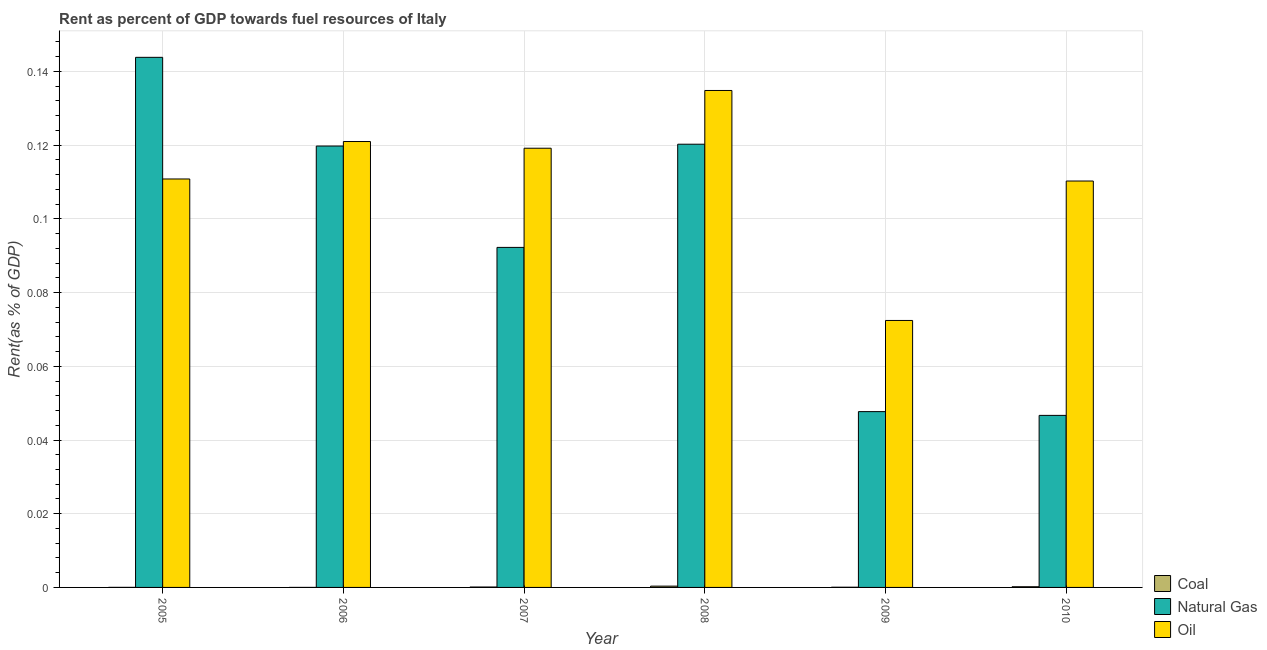How many different coloured bars are there?
Your answer should be compact. 3. Are the number of bars per tick equal to the number of legend labels?
Your response must be concise. Yes. How many bars are there on the 1st tick from the left?
Offer a terse response. 3. In how many cases, is the number of bars for a given year not equal to the number of legend labels?
Your answer should be very brief. 0. What is the rent towards coal in 2010?
Keep it short and to the point. 0. Across all years, what is the maximum rent towards natural gas?
Keep it short and to the point. 0.14. Across all years, what is the minimum rent towards natural gas?
Make the answer very short. 0.05. In which year was the rent towards coal minimum?
Make the answer very short. 2006. What is the total rent towards natural gas in the graph?
Your response must be concise. 0.57. What is the difference between the rent towards natural gas in 2008 and that in 2010?
Your answer should be compact. 0.07. What is the difference between the rent towards oil in 2006 and the rent towards natural gas in 2005?
Make the answer very short. 0.01. What is the average rent towards oil per year?
Provide a short and direct response. 0.11. In the year 2005, what is the difference between the rent towards oil and rent towards coal?
Your response must be concise. 0. In how many years, is the rent towards natural gas greater than 0.064 %?
Provide a succinct answer. 4. What is the ratio of the rent towards coal in 2005 to that in 2007?
Offer a very short reply. 0.14. What is the difference between the highest and the second highest rent towards natural gas?
Keep it short and to the point. 0.02. What is the difference between the highest and the lowest rent towards natural gas?
Keep it short and to the point. 0.1. What does the 3rd bar from the left in 2009 represents?
Your response must be concise. Oil. What does the 3rd bar from the right in 2005 represents?
Offer a very short reply. Coal. How many bars are there?
Provide a succinct answer. 18. Are all the bars in the graph horizontal?
Your answer should be very brief. No. Are the values on the major ticks of Y-axis written in scientific E-notation?
Your answer should be very brief. No. Does the graph contain any zero values?
Your response must be concise. No. How are the legend labels stacked?
Offer a very short reply. Vertical. What is the title of the graph?
Your answer should be very brief. Rent as percent of GDP towards fuel resources of Italy. What is the label or title of the Y-axis?
Make the answer very short. Rent(as % of GDP). What is the Rent(as % of GDP) of Coal in 2005?
Your answer should be very brief. 1.52938665315344e-5. What is the Rent(as % of GDP) of Natural Gas in 2005?
Provide a short and direct response. 0.14. What is the Rent(as % of GDP) in Oil in 2005?
Make the answer very short. 0.11. What is the Rent(as % of GDP) of Coal in 2006?
Offer a terse response. 5.16849671469394e-6. What is the Rent(as % of GDP) of Natural Gas in 2006?
Your answer should be compact. 0.12. What is the Rent(as % of GDP) of Oil in 2006?
Provide a short and direct response. 0.12. What is the Rent(as % of GDP) in Coal in 2007?
Your answer should be compact. 0. What is the Rent(as % of GDP) in Natural Gas in 2007?
Offer a very short reply. 0.09. What is the Rent(as % of GDP) of Oil in 2007?
Make the answer very short. 0.12. What is the Rent(as % of GDP) of Coal in 2008?
Give a very brief answer. 0. What is the Rent(as % of GDP) of Natural Gas in 2008?
Provide a short and direct response. 0.12. What is the Rent(as % of GDP) in Oil in 2008?
Give a very brief answer. 0.13. What is the Rent(as % of GDP) of Coal in 2009?
Keep it short and to the point. 5.380155600468061e-5. What is the Rent(as % of GDP) of Natural Gas in 2009?
Provide a short and direct response. 0.05. What is the Rent(as % of GDP) of Oil in 2009?
Provide a short and direct response. 0.07. What is the Rent(as % of GDP) in Coal in 2010?
Provide a short and direct response. 0. What is the Rent(as % of GDP) of Natural Gas in 2010?
Make the answer very short. 0.05. What is the Rent(as % of GDP) of Oil in 2010?
Provide a succinct answer. 0.11. Across all years, what is the maximum Rent(as % of GDP) in Coal?
Provide a short and direct response. 0. Across all years, what is the maximum Rent(as % of GDP) of Natural Gas?
Your answer should be compact. 0.14. Across all years, what is the maximum Rent(as % of GDP) of Oil?
Offer a very short reply. 0.13. Across all years, what is the minimum Rent(as % of GDP) of Coal?
Your response must be concise. 5.16849671469394e-6. Across all years, what is the minimum Rent(as % of GDP) of Natural Gas?
Your answer should be very brief. 0.05. Across all years, what is the minimum Rent(as % of GDP) in Oil?
Offer a very short reply. 0.07. What is the total Rent(as % of GDP) in Coal in the graph?
Keep it short and to the point. 0. What is the total Rent(as % of GDP) in Natural Gas in the graph?
Give a very brief answer. 0.57. What is the total Rent(as % of GDP) of Oil in the graph?
Offer a terse response. 0.67. What is the difference between the Rent(as % of GDP) in Natural Gas in 2005 and that in 2006?
Provide a succinct answer. 0.02. What is the difference between the Rent(as % of GDP) of Oil in 2005 and that in 2006?
Provide a short and direct response. -0.01. What is the difference between the Rent(as % of GDP) in Coal in 2005 and that in 2007?
Your answer should be very brief. -0. What is the difference between the Rent(as % of GDP) in Natural Gas in 2005 and that in 2007?
Provide a succinct answer. 0.05. What is the difference between the Rent(as % of GDP) of Oil in 2005 and that in 2007?
Provide a short and direct response. -0.01. What is the difference between the Rent(as % of GDP) in Coal in 2005 and that in 2008?
Give a very brief answer. -0. What is the difference between the Rent(as % of GDP) of Natural Gas in 2005 and that in 2008?
Your answer should be very brief. 0.02. What is the difference between the Rent(as % of GDP) of Oil in 2005 and that in 2008?
Offer a terse response. -0.02. What is the difference between the Rent(as % of GDP) of Natural Gas in 2005 and that in 2009?
Make the answer very short. 0.1. What is the difference between the Rent(as % of GDP) of Oil in 2005 and that in 2009?
Offer a very short reply. 0.04. What is the difference between the Rent(as % of GDP) in Coal in 2005 and that in 2010?
Provide a short and direct response. -0. What is the difference between the Rent(as % of GDP) in Natural Gas in 2005 and that in 2010?
Your answer should be compact. 0.1. What is the difference between the Rent(as % of GDP) of Oil in 2005 and that in 2010?
Your response must be concise. 0. What is the difference between the Rent(as % of GDP) of Coal in 2006 and that in 2007?
Make the answer very short. -0. What is the difference between the Rent(as % of GDP) in Natural Gas in 2006 and that in 2007?
Make the answer very short. 0.03. What is the difference between the Rent(as % of GDP) of Oil in 2006 and that in 2007?
Provide a short and direct response. 0. What is the difference between the Rent(as % of GDP) of Coal in 2006 and that in 2008?
Your response must be concise. -0. What is the difference between the Rent(as % of GDP) of Natural Gas in 2006 and that in 2008?
Keep it short and to the point. -0. What is the difference between the Rent(as % of GDP) of Oil in 2006 and that in 2008?
Your answer should be very brief. -0.01. What is the difference between the Rent(as % of GDP) in Coal in 2006 and that in 2009?
Ensure brevity in your answer.  -0. What is the difference between the Rent(as % of GDP) of Natural Gas in 2006 and that in 2009?
Ensure brevity in your answer.  0.07. What is the difference between the Rent(as % of GDP) of Oil in 2006 and that in 2009?
Offer a terse response. 0.05. What is the difference between the Rent(as % of GDP) of Coal in 2006 and that in 2010?
Provide a short and direct response. -0. What is the difference between the Rent(as % of GDP) of Natural Gas in 2006 and that in 2010?
Offer a very short reply. 0.07. What is the difference between the Rent(as % of GDP) of Oil in 2006 and that in 2010?
Make the answer very short. 0.01. What is the difference between the Rent(as % of GDP) of Coal in 2007 and that in 2008?
Give a very brief answer. -0. What is the difference between the Rent(as % of GDP) in Natural Gas in 2007 and that in 2008?
Make the answer very short. -0.03. What is the difference between the Rent(as % of GDP) in Oil in 2007 and that in 2008?
Your answer should be very brief. -0.02. What is the difference between the Rent(as % of GDP) in Natural Gas in 2007 and that in 2009?
Offer a very short reply. 0.04. What is the difference between the Rent(as % of GDP) of Oil in 2007 and that in 2009?
Provide a short and direct response. 0.05. What is the difference between the Rent(as % of GDP) in Coal in 2007 and that in 2010?
Your response must be concise. -0. What is the difference between the Rent(as % of GDP) in Natural Gas in 2007 and that in 2010?
Ensure brevity in your answer.  0.05. What is the difference between the Rent(as % of GDP) of Oil in 2007 and that in 2010?
Keep it short and to the point. 0.01. What is the difference between the Rent(as % of GDP) in Natural Gas in 2008 and that in 2009?
Offer a terse response. 0.07. What is the difference between the Rent(as % of GDP) in Oil in 2008 and that in 2009?
Your answer should be compact. 0.06. What is the difference between the Rent(as % of GDP) in Natural Gas in 2008 and that in 2010?
Provide a succinct answer. 0.07. What is the difference between the Rent(as % of GDP) of Oil in 2008 and that in 2010?
Provide a short and direct response. 0.02. What is the difference between the Rent(as % of GDP) of Coal in 2009 and that in 2010?
Offer a terse response. -0. What is the difference between the Rent(as % of GDP) in Oil in 2009 and that in 2010?
Provide a succinct answer. -0.04. What is the difference between the Rent(as % of GDP) of Coal in 2005 and the Rent(as % of GDP) of Natural Gas in 2006?
Give a very brief answer. -0.12. What is the difference between the Rent(as % of GDP) in Coal in 2005 and the Rent(as % of GDP) in Oil in 2006?
Your response must be concise. -0.12. What is the difference between the Rent(as % of GDP) in Natural Gas in 2005 and the Rent(as % of GDP) in Oil in 2006?
Your answer should be compact. 0.02. What is the difference between the Rent(as % of GDP) of Coal in 2005 and the Rent(as % of GDP) of Natural Gas in 2007?
Keep it short and to the point. -0.09. What is the difference between the Rent(as % of GDP) in Coal in 2005 and the Rent(as % of GDP) in Oil in 2007?
Keep it short and to the point. -0.12. What is the difference between the Rent(as % of GDP) in Natural Gas in 2005 and the Rent(as % of GDP) in Oil in 2007?
Your answer should be very brief. 0.02. What is the difference between the Rent(as % of GDP) in Coal in 2005 and the Rent(as % of GDP) in Natural Gas in 2008?
Offer a very short reply. -0.12. What is the difference between the Rent(as % of GDP) in Coal in 2005 and the Rent(as % of GDP) in Oil in 2008?
Your response must be concise. -0.13. What is the difference between the Rent(as % of GDP) in Natural Gas in 2005 and the Rent(as % of GDP) in Oil in 2008?
Offer a terse response. 0.01. What is the difference between the Rent(as % of GDP) of Coal in 2005 and the Rent(as % of GDP) of Natural Gas in 2009?
Offer a very short reply. -0.05. What is the difference between the Rent(as % of GDP) of Coal in 2005 and the Rent(as % of GDP) of Oil in 2009?
Offer a terse response. -0.07. What is the difference between the Rent(as % of GDP) of Natural Gas in 2005 and the Rent(as % of GDP) of Oil in 2009?
Offer a terse response. 0.07. What is the difference between the Rent(as % of GDP) of Coal in 2005 and the Rent(as % of GDP) of Natural Gas in 2010?
Make the answer very short. -0.05. What is the difference between the Rent(as % of GDP) of Coal in 2005 and the Rent(as % of GDP) of Oil in 2010?
Offer a very short reply. -0.11. What is the difference between the Rent(as % of GDP) of Natural Gas in 2005 and the Rent(as % of GDP) of Oil in 2010?
Provide a succinct answer. 0.03. What is the difference between the Rent(as % of GDP) in Coal in 2006 and the Rent(as % of GDP) in Natural Gas in 2007?
Provide a short and direct response. -0.09. What is the difference between the Rent(as % of GDP) of Coal in 2006 and the Rent(as % of GDP) of Oil in 2007?
Ensure brevity in your answer.  -0.12. What is the difference between the Rent(as % of GDP) of Natural Gas in 2006 and the Rent(as % of GDP) of Oil in 2007?
Your answer should be compact. 0. What is the difference between the Rent(as % of GDP) of Coal in 2006 and the Rent(as % of GDP) of Natural Gas in 2008?
Offer a terse response. -0.12. What is the difference between the Rent(as % of GDP) in Coal in 2006 and the Rent(as % of GDP) in Oil in 2008?
Offer a terse response. -0.13. What is the difference between the Rent(as % of GDP) in Natural Gas in 2006 and the Rent(as % of GDP) in Oil in 2008?
Ensure brevity in your answer.  -0.02. What is the difference between the Rent(as % of GDP) in Coal in 2006 and the Rent(as % of GDP) in Natural Gas in 2009?
Ensure brevity in your answer.  -0.05. What is the difference between the Rent(as % of GDP) of Coal in 2006 and the Rent(as % of GDP) of Oil in 2009?
Keep it short and to the point. -0.07. What is the difference between the Rent(as % of GDP) of Natural Gas in 2006 and the Rent(as % of GDP) of Oil in 2009?
Make the answer very short. 0.05. What is the difference between the Rent(as % of GDP) in Coal in 2006 and the Rent(as % of GDP) in Natural Gas in 2010?
Give a very brief answer. -0.05. What is the difference between the Rent(as % of GDP) of Coal in 2006 and the Rent(as % of GDP) of Oil in 2010?
Provide a succinct answer. -0.11. What is the difference between the Rent(as % of GDP) in Natural Gas in 2006 and the Rent(as % of GDP) in Oil in 2010?
Keep it short and to the point. 0.01. What is the difference between the Rent(as % of GDP) of Coal in 2007 and the Rent(as % of GDP) of Natural Gas in 2008?
Keep it short and to the point. -0.12. What is the difference between the Rent(as % of GDP) in Coal in 2007 and the Rent(as % of GDP) in Oil in 2008?
Make the answer very short. -0.13. What is the difference between the Rent(as % of GDP) in Natural Gas in 2007 and the Rent(as % of GDP) in Oil in 2008?
Offer a terse response. -0.04. What is the difference between the Rent(as % of GDP) of Coal in 2007 and the Rent(as % of GDP) of Natural Gas in 2009?
Offer a terse response. -0.05. What is the difference between the Rent(as % of GDP) in Coal in 2007 and the Rent(as % of GDP) in Oil in 2009?
Your response must be concise. -0.07. What is the difference between the Rent(as % of GDP) of Natural Gas in 2007 and the Rent(as % of GDP) of Oil in 2009?
Provide a short and direct response. 0.02. What is the difference between the Rent(as % of GDP) of Coal in 2007 and the Rent(as % of GDP) of Natural Gas in 2010?
Keep it short and to the point. -0.05. What is the difference between the Rent(as % of GDP) of Coal in 2007 and the Rent(as % of GDP) of Oil in 2010?
Provide a short and direct response. -0.11. What is the difference between the Rent(as % of GDP) in Natural Gas in 2007 and the Rent(as % of GDP) in Oil in 2010?
Your answer should be compact. -0.02. What is the difference between the Rent(as % of GDP) in Coal in 2008 and the Rent(as % of GDP) in Natural Gas in 2009?
Make the answer very short. -0.05. What is the difference between the Rent(as % of GDP) of Coal in 2008 and the Rent(as % of GDP) of Oil in 2009?
Your response must be concise. -0.07. What is the difference between the Rent(as % of GDP) in Natural Gas in 2008 and the Rent(as % of GDP) in Oil in 2009?
Provide a succinct answer. 0.05. What is the difference between the Rent(as % of GDP) of Coal in 2008 and the Rent(as % of GDP) of Natural Gas in 2010?
Keep it short and to the point. -0.05. What is the difference between the Rent(as % of GDP) in Coal in 2008 and the Rent(as % of GDP) in Oil in 2010?
Offer a terse response. -0.11. What is the difference between the Rent(as % of GDP) of Natural Gas in 2008 and the Rent(as % of GDP) of Oil in 2010?
Ensure brevity in your answer.  0.01. What is the difference between the Rent(as % of GDP) in Coal in 2009 and the Rent(as % of GDP) in Natural Gas in 2010?
Offer a very short reply. -0.05. What is the difference between the Rent(as % of GDP) of Coal in 2009 and the Rent(as % of GDP) of Oil in 2010?
Ensure brevity in your answer.  -0.11. What is the difference between the Rent(as % of GDP) of Natural Gas in 2009 and the Rent(as % of GDP) of Oil in 2010?
Provide a succinct answer. -0.06. What is the average Rent(as % of GDP) of Coal per year?
Offer a terse response. 0. What is the average Rent(as % of GDP) in Natural Gas per year?
Provide a short and direct response. 0.1. What is the average Rent(as % of GDP) in Oil per year?
Offer a very short reply. 0.11. In the year 2005, what is the difference between the Rent(as % of GDP) in Coal and Rent(as % of GDP) in Natural Gas?
Give a very brief answer. -0.14. In the year 2005, what is the difference between the Rent(as % of GDP) of Coal and Rent(as % of GDP) of Oil?
Ensure brevity in your answer.  -0.11. In the year 2005, what is the difference between the Rent(as % of GDP) of Natural Gas and Rent(as % of GDP) of Oil?
Your response must be concise. 0.03. In the year 2006, what is the difference between the Rent(as % of GDP) in Coal and Rent(as % of GDP) in Natural Gas?
Provide a short and direct response. -0.12. In the year 2006, what is the difference between the Rent(as % of GDP) in Coal and Rent(as % of GDP) in Oil?
Make the answer very short. -0.12. In the year 2006, what is the difference between the Rent(as % of GDP) of Natural Gas and Rent(as % of GDP) of Oil?
Your response must be concise. -0. In the year 2007, what is the difference between the Rent(as % of GDP) in Coal and Rent(as % of GDP) in Natural Gas?
Offer a terse response. -0.09. In the year 2007, what is the difference between the Rent(as % of GDP) of Coal and Rent(as % of GDP) of Oil?
Give a very brief answer. -0.12. In the year 2007, what is the difference between the Rent(as % of GDP) of Natural Gas and Rent(as % of GDP) of Oil?
Your response must be concise. -0.03. In the year 2008, what is the difference between the Rent(as % of GDP) in Coal and Rent(as % of GDP) in Natural Gas?
Provide a short and direct response. -0.12. In the year 2008, what is the difference between the Rent(as % of GDP) in Coal and Rent(as % of GDP) in Oil?
Your response must be concise. -0.13. In the year 2008, what is the difference between the Rent(as % of GDP) of Natural Gas and Rent(as % of GDP) of Oil?
Provide a short and direct response. -0.01. In the year 2009, what is the difference between the Rent(as % of GDP) of Coal and Rent(as % of GDP) of Natural Gas?
Make the answer very short. -0.05. In the year 2009, what is the difference between the Rent(as % of GDP) in Coal and Rent(as % of GDP) in Oil?
Give a very brief answer. -0.07. In the year 2009, what is the difference between the Rent(as % of GDP) in Natural Gas and Rent(as % of GDP) in Oil?
Offer a very short reply. -0.02. In the year 2010, what is the difference between the Rent(as % of GDP) in Coal and Rent(as % of GDP) in Natural Gas?
Give a very brief answer. -0.05. In the year 2010, what is the difference between the Rent(as % of GDP) of Coal and Rent(as % of GDP) of Oil?
Provide a succinct answer. -0.11. In the year 2010, what is the difference between the Rent(as % of GDP) of Natural Gas and Rent(as % of GDP) of Oil?
Provide a succinct answer. -0.06. What is the ratio of the Rent(as % of GDP) in Coal in 2005 to that in 2006?
Your answer should be compact. 2.96. What is the ratio of the Rent(as % of GDP) in Natural Gas in 2005 to that in 2006?
Keep it short and to the point. 1.2. What is the ratio of the Rent(as % of GDP) in Oil in 2005 to that in 2006?
Your answer should be compact. 0.92. What is the ratio of the Rent(as % of GDP) of Coal in 2005 to that in 2007?
Provide a succinct answer. 0.14. What is the ratio of the Rent(as % of GDP) of Natural Gas in 2005 to that in 2007?
Provide a succinct answer. 1.56. What is the ratio of the Rent(as % of GDP) of Oil in 2005 to that in 2007?
Provide a succinct answer. 0.93. What is the ratio of the Rent(as % of GDP) in Coal in 2005 to that in 2008?
Keep it short and to the point. 0.04. What is the ratio of the Rent(as % of GDP) of Natural Gas in 2005 to that in 2008?
Ensure brevity in your answer.  1.2. What is the ratio of the Rent(as % of GDP) in Oil in 2005 to that in 2008?
Keep it short and to the point. 0.82. What is the ratio of the Rent(as % of GDP) in Coal in 2005 to that in 2009?
Keep it short and to the point. 0.28. What is the ratio of the Rent(as % of GDP) in Natural Gas in 2005 to that in 2009?
Your answer should be very brief. 3.02. What is the ratio of the Rent(as % of GDP) of Oil in 2005 to that in 2009?
Make the answer very short. 1.53. What is the ratio of the Rent(as % of GDP) in Coal in 2005 to that in 2010?
Your answer should be very brief. 0.08. What is the ratio of the Rent(as % of GDP) in Natural Gas in 2005 to that in 2010?
Make the answer very short. 3.08. What is the ratio of the Rent(as % of GDP) in Oil in 2005 to that in 2010?
Offer a very short reply. 1. What is the ratio of the Rent(as % of GDP) in Coal in 2006 to that in 2007?
Make the answer very short. 0.05. What is the ratio of the Rent(as % of GDP) in Natural Gas in 2006 to that in 2007?
Your response must be concise. 1.3. What is the ratio of the Rent(as % of GDP) in Oil in 2006 to that in 2007?
Keep it short and to the point. 1.02. What is the ratio of the Rent(as % of GDP) of Coal in 2006 to that in 2008?
Offer a very short reply. 0.01. What is the ratio of the Rent(as % of GDP) of Oil in 2006 to that in 2008?
Your response must be concise. 0.9. What is the ratio of the Rent(as % of GDP) in Coal in 2006 to that in 2009?
Provide a short and direct response. 0.1. What is the ratio of the Rent(as % of GDP) of Natural Gas in 2006 to that in 2009?
Make the answer very short. 2.51. What is the ratio of the Rent(as % of GDP) in Oil in 2006 to that in 2009?
Your answer should be compact. 1.67. What is the ratio of the Rent(as % of GDP) in Coal in 2006 to that in 2010?
Your answer should be very brief. 0.03. What is the ratio of the Rent(as % of GDP) of Natural Gas in 2006 to that in 2010?
Offer a terse response. 2.57. What is the ratio of the Rent(as % of GDP) of Oil in 2006 to that in 2010?
Offer a terse response. 1.1. What is the ratio of the Rent(as % of GDP) of Coal in 2007 to that in 2008?
Provide a succinct answer. 0.32. What is the ratio of the Rent(as % of GDP) in Natural Gas in 2007 to that in 2008?
Provide a short and direct response. 0.77. What is the ratio of the Rent(as % of GDP) of Oil in 2007 to that in 2008?
Ensure brevity in your answer.  0.88. What is the ratio of the Rent(as % of GDP) of Coal in 2007 to that in 2009?
Give a very brief answer. 2.07. What is the ratio of the Rent(as % of GDP) in Natural Gas in 2007 to that in 2009?
Make the answer very short. 1.93. What is the ratio of the Rent(as % of GDP) of Oil in 2007 to that in 2009?
Your response must be concise. 1.65. What is the ratio of the Rent(as % of GDP) of Coal in 2007 to that in 2010?
Make the answer very short. 0.6. What is the ratio of the Rent(as % of GDP) of Natural Gas in 2007 to that in 2010?
Offer a terse response. 1.98. What is the ratio of the Rent(as % of GDP) in Oil in 2007 to that in 2010?
Ensure brevity in your answer.  1.08. What is the ratio of the Rent(as % of GDP) in Coal in 2008 to that in 2009?
Your answer should be compact. 6.54. What is the ratio of the Rent(as % of GDP) of Natural Gas in 2008 to that in 2009?
Offer a terse response. 2.52. What is the ratio of the Rent(as % of GDP) of Oil in 2008 to that in 2009?
Offer a terse response. 1.86. What is the ratio of the Rent(as % of GDP) of Coal in 2008 to that in 2010?
Your response must be concise. 1.89. What is the ratio of the Rent(as % of GDP) of Natural Gas in 2008 to that in 2010?
Your answer should be compact. 2.58. What is the ratio of the Rent(as % of GDP) of Oil in 2008 to that in 2010?
Offer a terse response. 1.22. What is the ratio of the Rent(as % of GDP) of Coal in 2009 to that in 2010?
Ensure brevity in your answer.  0.29. What is the ratio of the Rent(as % of GDP) of Natural Gas in 2009 to that in 2010?
Provide a short and direct response. 1.02. What is the ratio of the Rent(as % of GDP) in Oil in 2009 to that in 2010?
Make the answer very short. 0.66. What is the difference between the highest and the second highest Rent(as % of GDP) in Natural Gas?
Your answer should be compact. 0.02. What is the difference between the highest and the second highest Rent(as % of GDP) of Oil?
Keep it short and to the point. 0.01. What is the difference between the highest and the lowest Rent(as % of GDP) of Coal?
Make the answer very short. 0. What is the difference between the highest and the lowest Rent(as % of GDP) in Natural Gas?
Offer a very short reply. 0.1. What is the difference between the highest and the lowest Rent(as % of GDP) in Oil?
Make the answer very short. 0.06. 